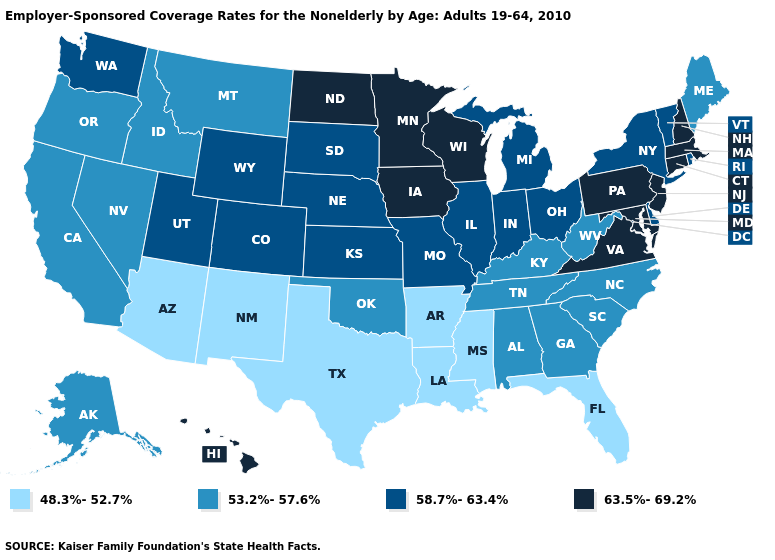Name the states that have a value in the range 63.5%-69.2%?
Give a very brief answer. Connecticut, Hawaii, Iowa, Maryland, Massachusetts, Minnesota, New Hampshire, New Jersey, North Dakota, Pennsylvania, Virginia, Wisconsin. Does Georgia have the same value as Montana?
Keep it brief. Yes. What is the highest value in the MidWest ?
Quick response, please. 63.5%-69.2%. Name the states that have a value in the range 48.3%-52.7%?
Answer briefly. Arizona, Arkansas, Florida, Louisiana, Mississippi, New Mexico, Texas. Among the states that border Alabama , which have the lowest value?
Short answer required. Florida, Mississippi. Does the map have missing data?
Concise answer only. No. What is the value of Wisconsin?
Be succinct. 63.5%-69.2%. Name the states that have a value in the range 48.3%-52.7%?
Quick response, please. Arizona, Arkansas, Florida, Louisiana, Mississippi, New Mexico, Texas. Does the first symbol in the legend represent the smallest category?
Give a very brief answer. Yes. What is the lowest value in the USA?
Write a very short answer. 48.3%-52.7%. Among the states that border Virginia , which have the highest value?
Short answer required. Maryland. What is the highest value in the USA?
Concise answer only. 63.5%-69.2%. Which states have the lowest value in the MidWest?
Keep it brief. Illinois, Indiana, Kansas, Michigan, Missouri, Nebraska, Ohio, South Dakota. Name the states that have a value in the range 53.2%-57.6%?
Be succinct. Alabama, Alaska, California, Georgia, Idaho, Kentucky, Maine, Montana, Nevada, North Carolina, Oklahoma, Oregon, South Carolina, Tennessee, West Virginia. What is the value of Idaho?
Short answer required. 53.2%-57.6%. 